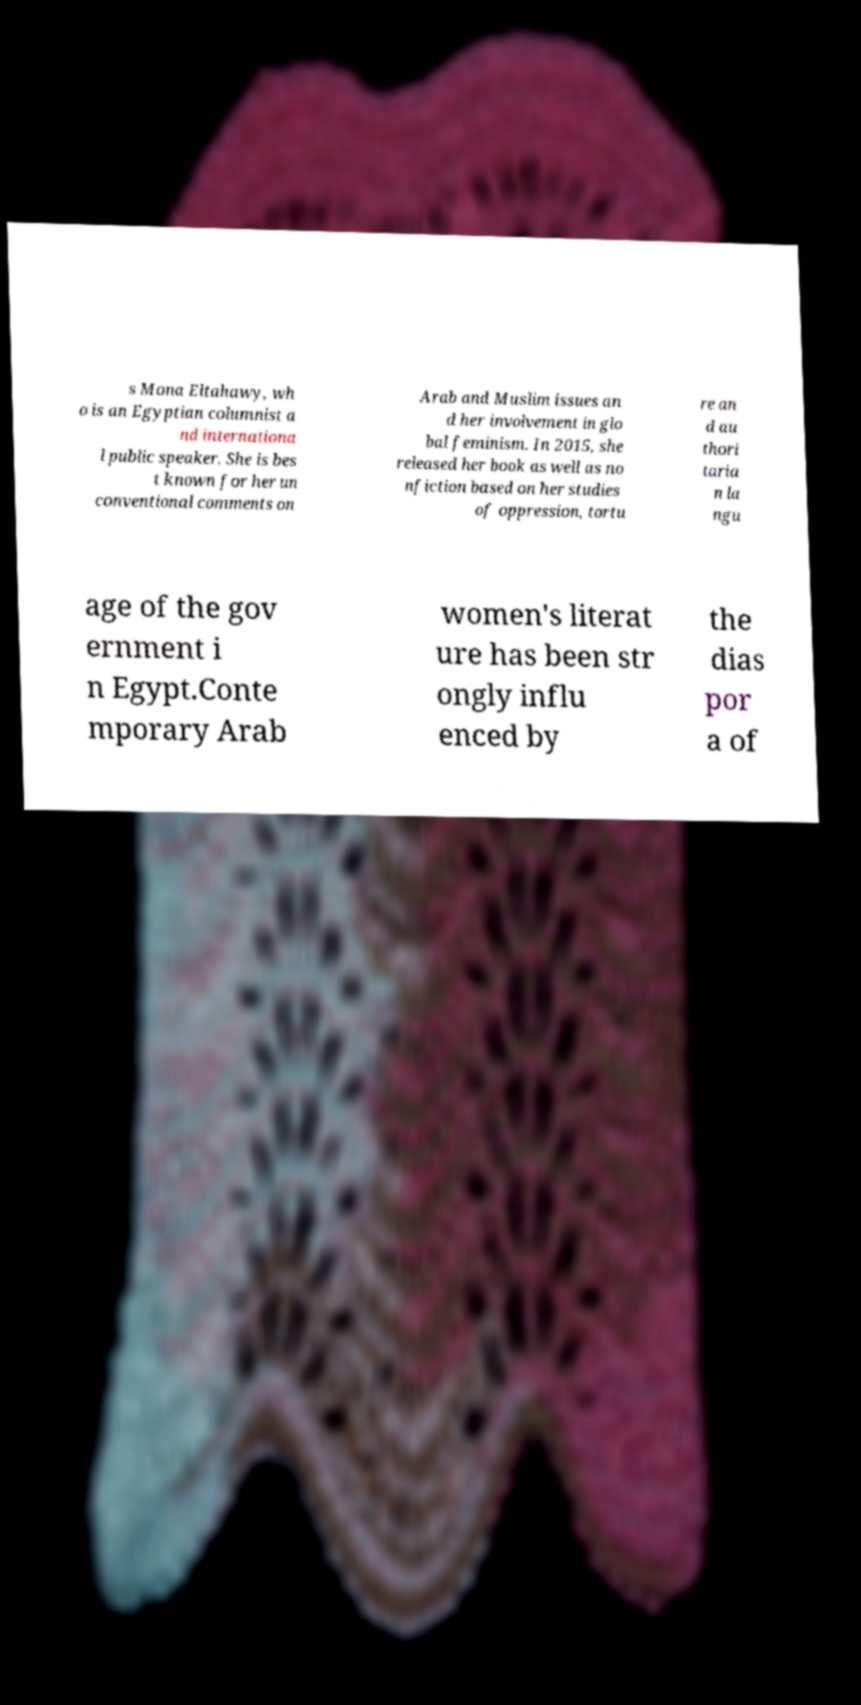Could you extract and type out the text from this image? s Mona Eltahawy, wh o is an Egyptian columnist a nd internationa l public speaker. She is bes t known for her un conventional comments on Arab and Muslim issues an d her involvement in glo bal feminism. In 2015, she released her book as well as no nfiction based on her studies of oppression, tortu re an d au thori taria n la ngu age of the gov ernment i n Egypt.Conte mporary Arab women's literat ure has been str ongly influ enced by the dias por a of 